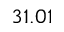Convert formula to latex. <formula><loc_0><loc_0><loc_500><loc_500>3 1 . 0 1</formula> 